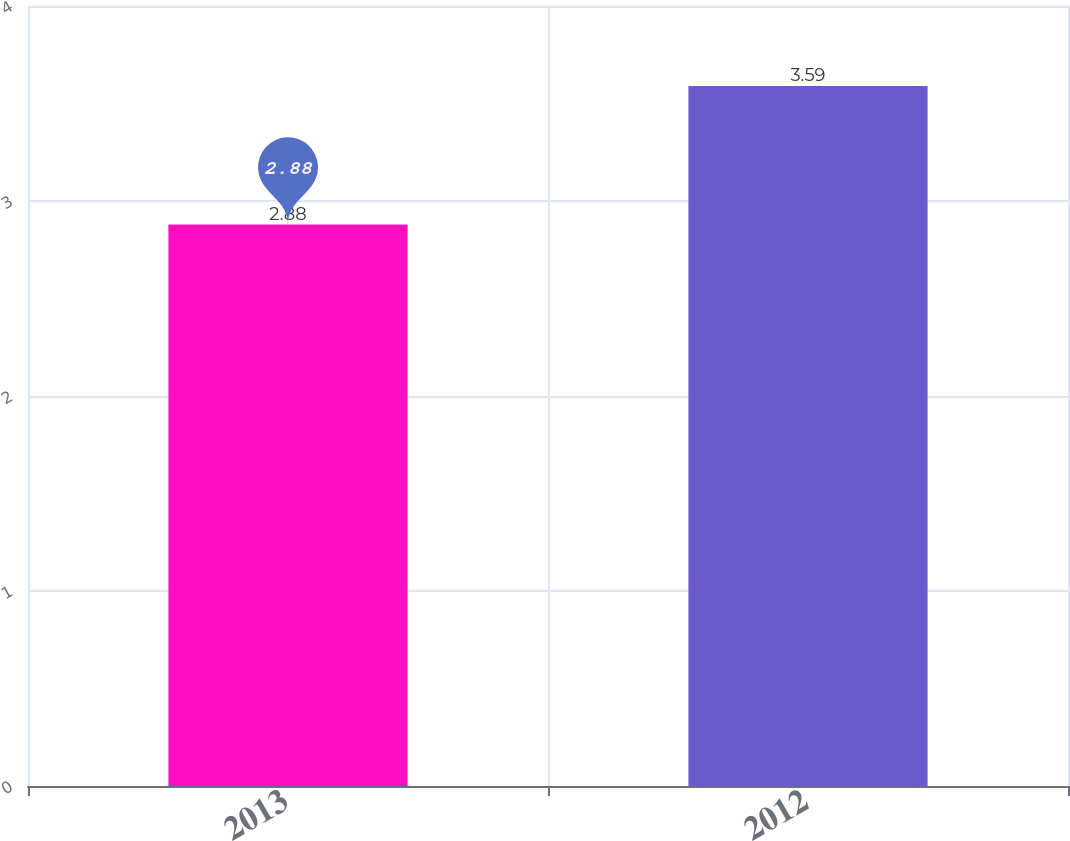Convert chart. <chart><loc_0><loc_0><loc_500><loc_500><bar_chart><fcel>2013<fcel>2012<nl><fcel>2.88<fcel>3.59<nl></chart> 